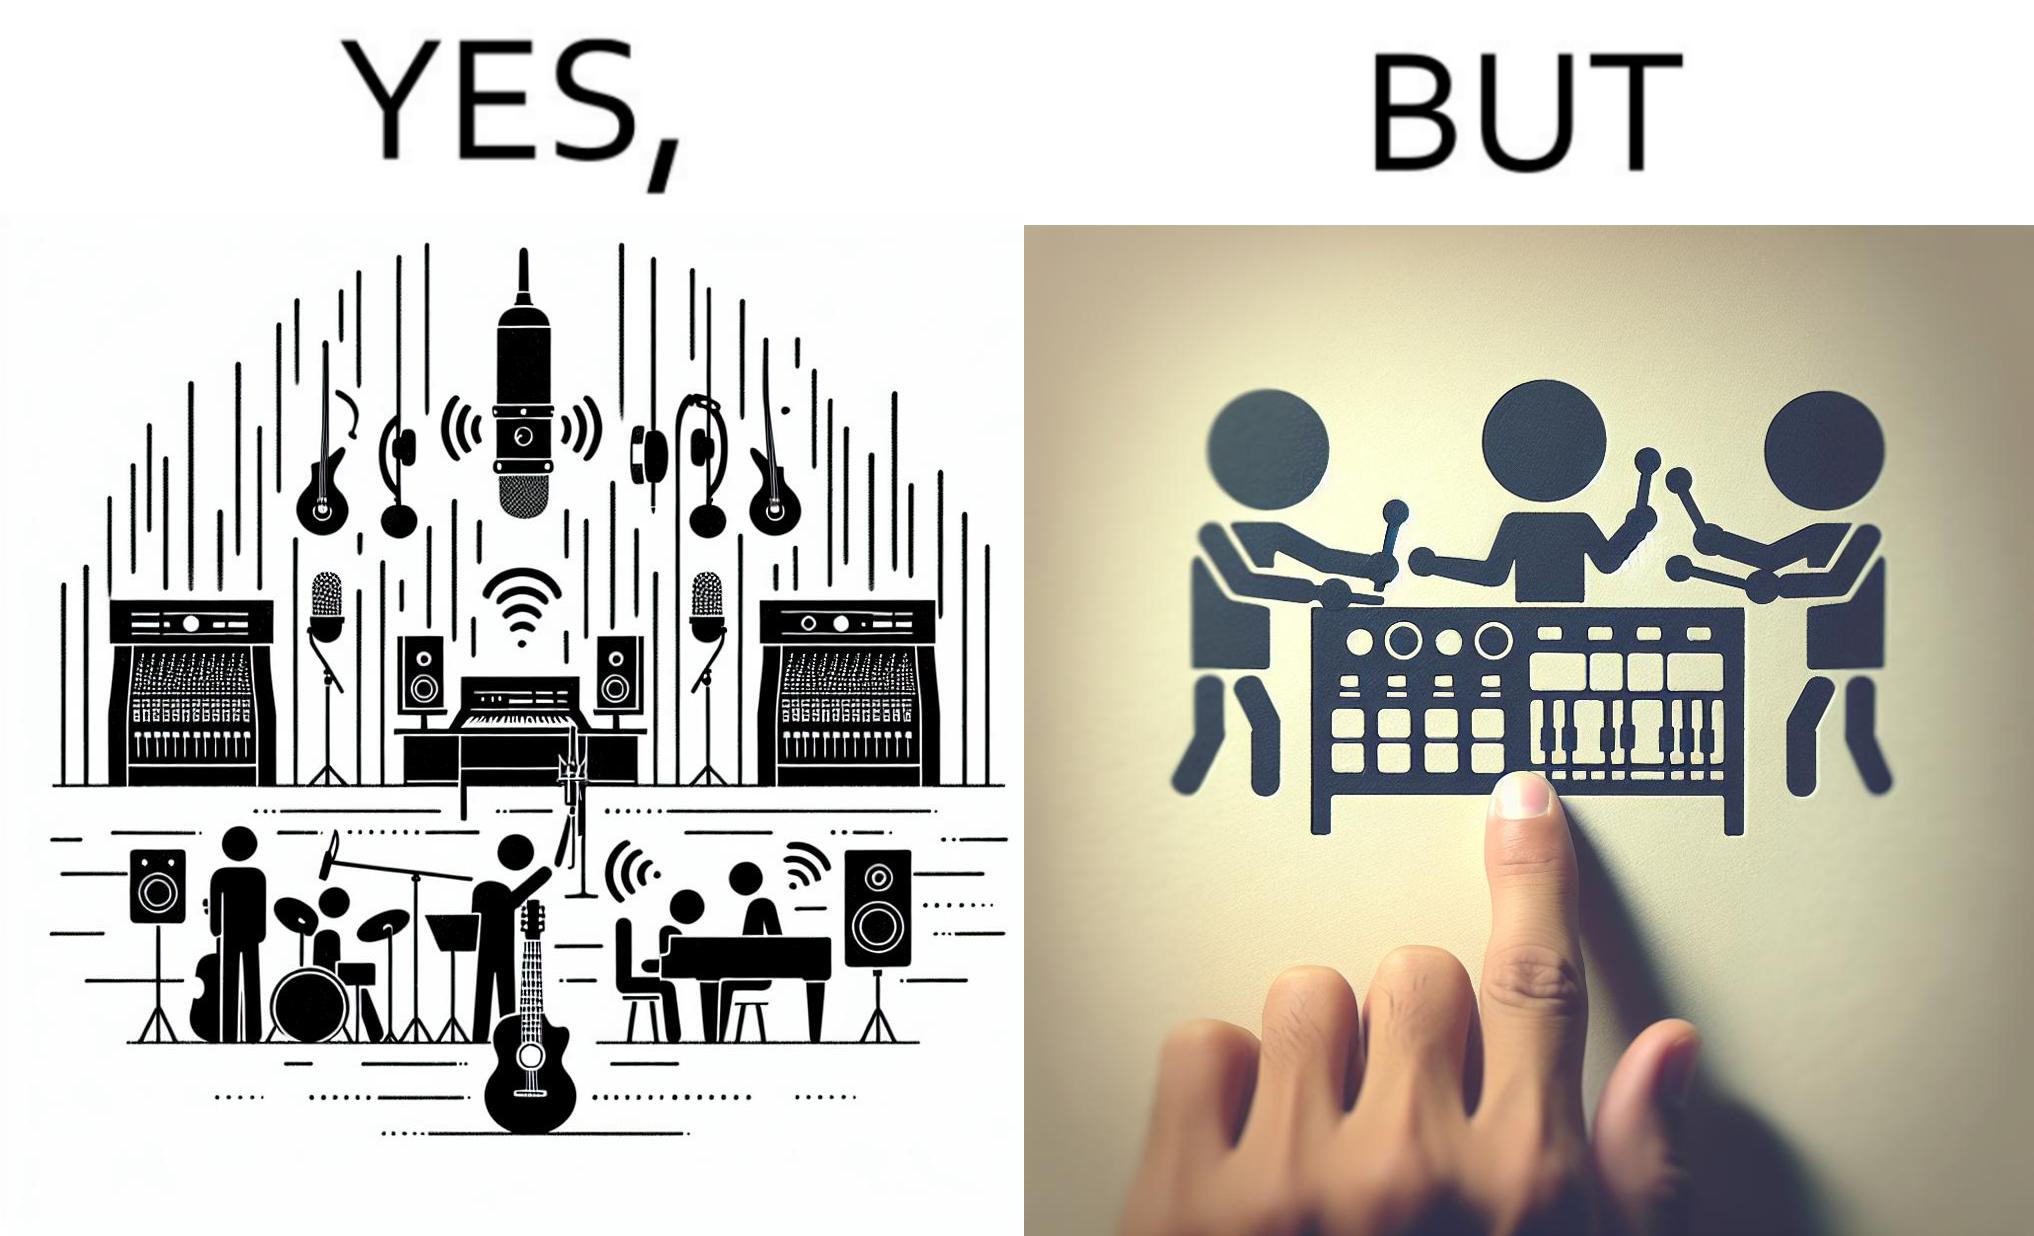Describe the contrast between the left and right parts of this image. In the left part of the image: The image shows a music studio with differnt kinds of instruments like guitar and saxophone, piano and recording  to make music. In the right part of the image: The image shows the view of an electornic equipment used to create music. It has buttons to record, play drums and other musical instruments. 